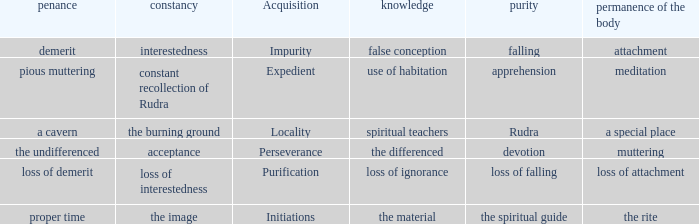 what's the constancy where permanence of the body is meditation Constant recollection of rudra. 